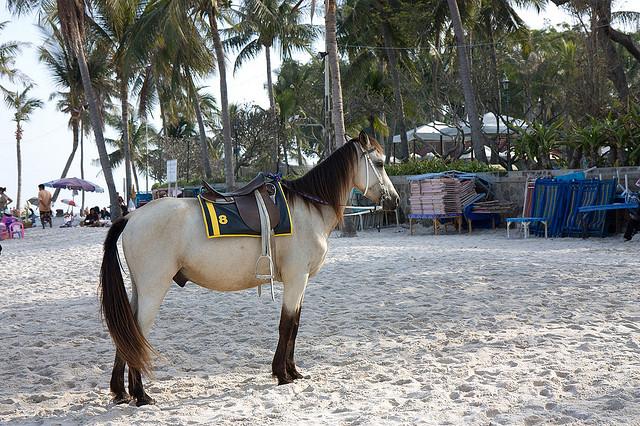Are there people on the beach?
Keep it brief. Yes. Why does the horse have a saddle on its back?
Concise answer only. To ride. What color is the horse?
Short answer required. White. 